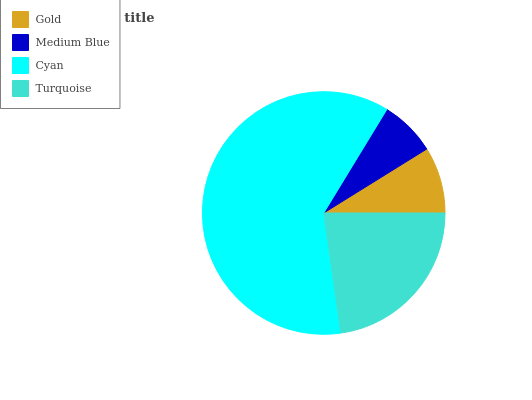Is Medium Blue the minimum?
Answer yes or no. Yes. Is Cyan the maximum?
Answer yes or no. Yes. Is Cyan the minimum?
Answer yes or no. No. Is Medium Blue the maximum?
Answer yes or no. No. Is Cyan greater than Medium Blue?
Answer yes or no. Yes. Is Medium Blue less than Cyan?
Answer yes or no. Yes. Is Medium Blue greater than Cyan?
Answer yes or no. No. Is Cyan less than Medium Blue?
Answer yes or no. No. Is Turquoise the high median?
Answer yes or no. Yes. Is Gold the low median?
Answer yes or no. Yes. Is Medium Blue the high median?
Answer yes or no. No. Is Medium Blue the low median?
Answer yes or no. No. 